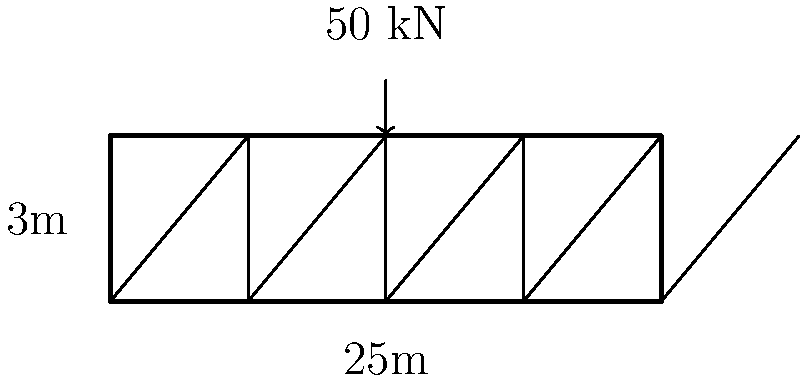A truss bridge spanning 25 meters with a height of 3 meters is subjected to a point load of 50 kN at its midpoint. The truss members are made of steel with a yield strength of 250 MPa and a cross-sectional area of 2000 mm². Assuming the load is equally distributed between the top and bottom chords, calculate the maximum axial force in the most stressed diagonal member. (Hint: Consider the method of joints and the 3-4-5 triangle rule) To solve this problem, we'll follow these steps:

1) First, we need to calculate the reaction forces at the supports. Since the load is at the midpoint, each support will bear half the total load:
   $R_A = R_B = 50 \text{ kN} / 2 = 25 \text{ kN}$

2) We'll focus on the joint at the midpoint where the load is applied. The vertical component of the force in the diagonal member must balance half of the applied load (25 kN).

3) The diagonal member forms a 3-4-5 right triangle with the vertical and horizontal members:
   - Vertical: 3m
   - Horizontal: 12.5m (half of 25m)
   - Diagonal: 13m (using Pythagorean theorem: $\sqrt{3^2 + 12.5^2} \approx 13$)

4) The ratio of the diagonal to the vertical is 13:3. We can use this to find the force in the diagonal:
   $\frac{F_{diagonal}}{25 \text{ kN}} = \frac{13}{3}$

5) Solving for $F_{diagonal}$:
   $F_{diagonal} = 25 \text{ kN} \times \frac{13}{3} \approx 108.33 \text{ kN}$

6) This is the maximum axial force in the most stressed diagonal member.

7) To verify if the member can withstand this force:
   Stress = Force / Area = $108.33 \times 10^3 \text{ N} / 2000 \text{ mm}^2 = 54.17 \text{ MPa}$
   This is well below the yield strength of 250 MPa, so the member is safe.
Answer: 108.33 kN 